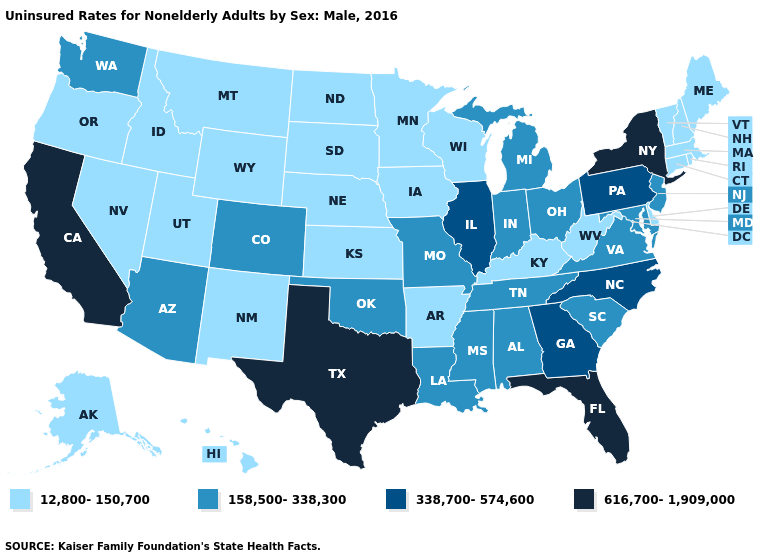What is the highest value in states that border West Virginia?
Short answer required. 338,700-574,600. What is the highest value in the West ?
Quick response, please. 616,700-1,909,000. Does Wyoming have a lower value than Delaware?
Write a very short answer. No. What is the value of South Carolina?
Short answer required. 158,500-338,300. Does the first symbol in the legend represent the smallest category?
Short answer required. Yes. Does the first symbol in the legend represent the smallest category?
Be succinct. Yes. What is the value of Nevada?
Write a very short answer. 12,800-150,700. Name the states that have a value in the range 12,800-150,700?
Write a very short answer. Alaska, Arkansas, Connecticut, Delaware, Hawaii, Idaho, Iowa, Kansas, Kentucky, Maine, Massachusetts, Minnesota, Montana, Nebraska, Nevada, New Hampshire, New Mexico, North Dakota, Oregon, Rhode Island, South Dakota, Utah, Vermont, West Virginia, Wisconsin, Wyoming. What is the highest value in the USA?
Concise answer only. 616,700-1,909,000. Which states have the lowest value in the West?
Write a very short answer. Alaska, Hawaii, Idaho, Montana, Nevada, New Mexico, Oregon, Utah, Wyoming. What is the value of North Dakota?
Short answer required. 12,800-150,700. How many symbols are there in the legend?
Concise answer only. 4. What is the highest value in the USA?
Quick response, please. 616,700-1,909,000. Name the states that have a value in the range 338,700-574,600?
Quick response, please. Georgia, Illinois, North Carolina, Pennsylvania. Name the states that have a value in the range 12,800-150,700?
Write a very short answer. Alaska, Arkansas, Connecticut, Delaware, Hawaii, Idaho, Iowa, Kansas, Kentucky, Maine, Massachusetts, Minnesota, Montana, Nebraska, Nevada, New Hampshire, New Mexico, North Dakota, Oregon, Rhode Island, South Dakota, Utah, Vermont, West Virginia, Wisconsin, Wyoming. 